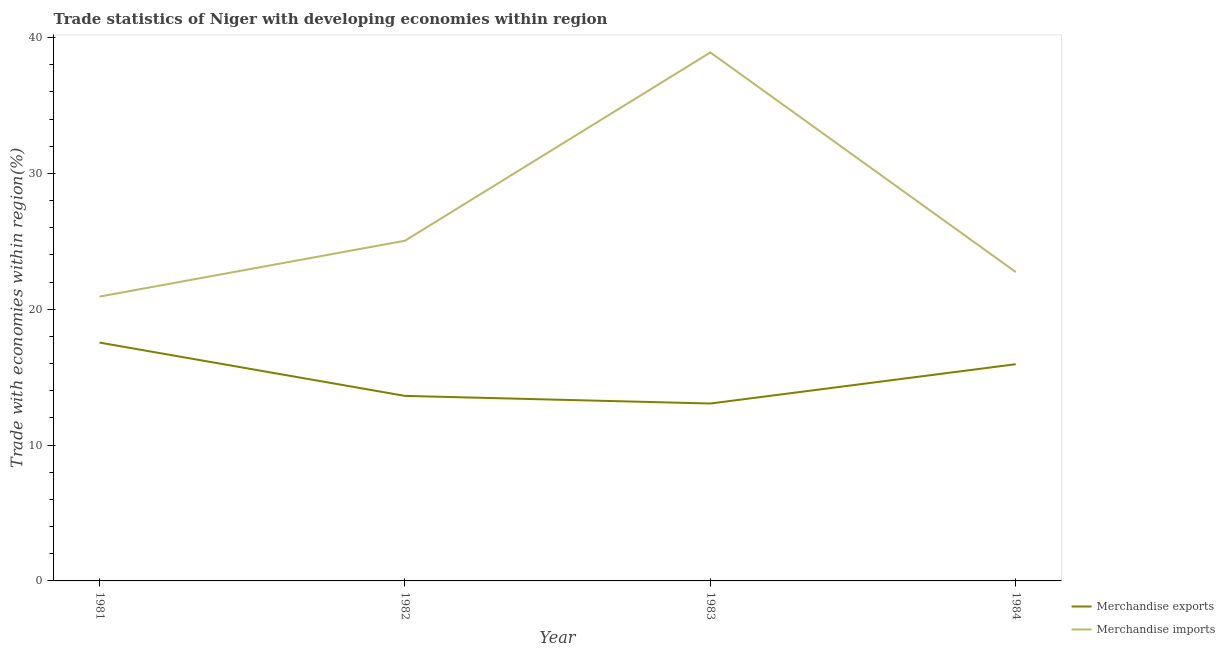How many different coloured lines are there?
Provide a succinct answer. 2. Does the line corresponding to merchandise imports intersect with the line corresponding to merchandise exports?
Your answer should be very brief. No. Is the number of lines equal to the number of legend labels?
Keep it short and to the point. Yes. What is the merchandise exports in 1983?
Give a very brief answer. 13.06. Across all years, what is the maximum merchandise imports?
Make the answer very short. 38.91. Across all years, what is the minimum merchandise imports?
Keep it short and to the point. 20.93. In which year was the merchandise imports maximum?
Your answer should be very brief. 1983. What is the total merchandise exports in the graph?
Provide a short and direct response. 60.18. What is the difference between the merchandise imports in 1981 and that in 1984?
Offer a terse response. -1.81. What is the difference between the merchandise exports in 1984 and the merchandise imports in 1983?
Your answer should be very brief. -22.95. What is the average merchandise imports per year?
Offer a terse response. 26.9. In the year 1981, what is the difference between the merchandise exports and merchandise imports?
Ensure brevity in your answer.  -3.38. What is the ratio of the merchandise exports in 1983 to that in 1984?
Make the answer very short. 0.82. What is the difference between the highest and the second highest merchandise imports?
Provide a short and direct response. 13.86. What is the difference between the highest and the lowest merchandise exports?
Offer a very short reply. 4.49. Is the sum of the merchandise imports in 1981 and 1984 greater than the maximum merchandise exports across all years?
Offer a terse response. Yes. Does the merchandise exports monotonically increase over the years?
Your response must be concise. No. Is the merchandise exports strictly greater than the merchandise imports over the years?
Provide a succinct answer. No. How many lines are there?
Give a very brief answer. 2. How many years are there in the graph?
Make the answer very short. 4. What is the difference between two consecutive major ticks on the Y-axis?
Ensure brevity in your answer.  10. Are the values on the major ticks of Y-axis written in scientific E-notation?
Provide a succinct answer. No. Does the graph contain any zero values?
Ensure brevity in your answer.  No. Does the graph contain grids?
Your response must be concise. No. How many legend labels are there?
Keep it short and to the point. 2. How are the legend labels stacked?
Your answer should be compact. Vertical. What is the title of the graph?
Give a very brief answer. Trade statistics of Niger with developing economies within region. Does "IMF concessional" appear as one of the legend labels in the graph?
Make the answer very short. No. What is the label or title of the X-axis?
Make the answer very short. Year. What is the label or title of the Y-axis?
Provide a short and direct response. Trade with economies within region(%). What is the Trade with economies within region(%) of Merchandise exports in 1981?
Offer a terse response. 17.55. What is the Trade with economies within region(%) in Merchandise imports in 1981?
Your answer should be very brief. 20.93. What is the Trade with economies within region(%) in Merchandise exports in 1982?
Give a very brief answer. 13.62. What is the Trade with economies within region(%) of Merchandise imports in 1982?
Your answer should be compact. 25.04. What is the Trade with economies within region(%) in Merchandise exports in 1983?
Keep it short and to the point. 13.06. What is the Trade with economies within region(%) of Merchandise imports in 1983?
Offer a terse response. 38.91. What is the Trade with economies within region(%) in Merchandise exports in 1984?
Provide a short and direct response. 15.95. What is the Trade with economies within region(%) in Merchandise imports in 1984?
Keep it short and to the point. 22.74. Across all years, what is the maximum Trade with economies within region(%) of Merchandise exports?
Your answer should be very brief. 17.55. Across all years, what is the maximum Trade with economies within region(%) of Merchandise imports?
Keep it short and to the point. 38.91. Across all years, what is the minimum Trade with economies within region(%) in Merchandise exports?
Your answer should be very brief. 13.06. Across all years, what is the minimum Trade with economies within region(%) in Merchandise imports?
Make the answer very short. 20.93. What is the total Trade with economies within region(%) of Merchandise exports in the graph?
Keep it short and to the point. 60.18. What is the total Trade with economies within region(%) of Merchandise imports in the graph?
Give a very brief answer. 107.62. What is the difference between the Trade with economies within region(%) in Merchandise exports in 1981 and that in 1982?
Your response must be concise. 3.93. What is the difference between the Trade with economies within region(%) in Merchandise imports in 1981 and that in 1982?
Your answer should be compact. -4.11. What is the difference between the Trade with economies within region(%) of Merchandise exports in 1981 and that in 1983?
Provide a succinct answer. 4.49. What is the difference between the Trade with economies within region(%) of Merchandise imports in 1981 and that in 1983?
Provide a short and direct response. -17.97. What is the difference between the Trade with economies within region(%) of Merchandise exports in 1981 and that in 1984?
Provide a short and direct response. 1.59. What is the difference between the Trade with economies within region(%) in Merchandise imports in 1981 and that in 1984?
Your answer should be compact. -1.81. What is the difference between the Trade with economies within region(%) in Merchandise exports in 1982 and that in 1983?
Provide a short and direct response. 0.56. What is the difference between the Trade with economies within region(%) in Merchandise imports in 1982 and that in 1983?
Keep it short and to the point. -13.86. What is the difference between the Trade with economies within region(%) of Merchandise exports in 1982 and that in 1984?
Your answer should be compact. -2.33. What is the difference between the Trade with economies within region(%) of Merchandise imports in 1982 and that in 1984?
Provide a short and direct response. 2.31. What is the difference between the Trade with economies within region(%) of Merchandise exports in 1983 and that in 1984?
Your answer should be very brief. -2.89. What is the difference between the Trade with economies within region(%) in Merchandise imports in 1983 and that in 1984?
Your response must be concise. 16.17. What is the difference between the Trade with economies within region(%) of Merchandise exports in 1981 and the Trade with economies within region(%) of Merchandise imports in 1982?
Your answer should be very brief. -7.5. What is the difference between the Trade with economies within region(%) in Merchandise exports in 1981 and the Trade with economies within region(%) in Merchandise imports in 1983?
Give a very brief answer. -21.36. What is the difference between the Trade with economies within region(%) of Merchandise exports in 1981 and the Trade with economies within region(%) of Merchandise imports in 1984?
Your response must be concise. -5.19. What is the difference between the Trade with economies within region(%) in Merchandise exports in 1982 and the Trade with economies within region(%) in Merchandise imports in 1983?
Offer a terse response. -25.28. What is the difference between the Trade with economies within region(%) in Merchandise exports in 1982 and the Trade with economies within region(%) in Merchandise imports in 1984?
Ensure brevity in your answer.  -9.12. What is the difference between the Trade with economies within region(%) of Merchandise exports in 1983 and the Trade with economies within region(%) of Merchandise imports in 1984?
Provide a short and direct response. -9.68. What is the average Trade with economies within region(%) in Merchandise exports per year?
Offer a terse response. 15.04. What is the average Trade with economies within region(%) of Merchandise imports per year?
Offer a very short reply. 26.9. In the year 1981, what is the difference between the Trade with economies within region(%) in Merchandise exports and Trade with economies within region(%) in Merchandise imports?
Provide a succinct answer. -3.38. In the year 1982, what is the difference between the Trade with economies within region(%) of Merchandise exports and Trade with economies within region(%) of Merchandise imports?
Give a very brief answer. -11.42. In the year 1983, what is the difference between the Trade with economies within region(%) in Merchandise exports and Trade with economies within region(%) in Merchandise imports?
Ensure brevity in your answer.  -25.85. In the year 1984, what is the difference between the Trade with economies within region(%) of Merchandise exports and Trade with economies within region(%) of Merchandise imports?
Your response must be concise. -6.78. What is the ratio of the Trade with economies within region(%) of Merchandise exports in 1981 to that in 1982?
Your answer should be very brief. 1.29. What is the ratio of the Trade with economies within region(%) of Merchandise imports in 1981 to that in 1982?
Your response must be concise. 0.84. What is the ratio of the Trade with economies within region(%) in Merchandise exports in 1981 to that in 1983?
Offer a very short reply. 1.34. What is the ratio of the Trade with economies within region(%) of Merchandise imports in 1981 to that in 1983?
Offer a terse response. 0.54. What is the ratio of the Trade with economies within region(%) in Merchandise exports in 1981 to that in 1984?
Give a very brief answer. 1.1. What is the ratio of the Trade with economies within region(%) of Merchandise imports in 1981 to that in 1984?
Make the answer very short. 0.92. What is the ratio of the Trade with economies within region(%) in Merchandise exports in 1982 to that in 1983?
Your answer should be compact. 1.04. What is the ratio of the Trade with economies within region(%) in Merchandise imports in 1982 to that in 1983?
Give a very brief answer. 0.64. What is the ratio of the Trade with economies within region(%) in Merchandise exports in 1982 to that in 1984?
Make the answer very short. 0.85. What is the ratio of the Trade with economies within region(%) of Merchandise imports in 1982 to that in 1984?
Offer a terse response. 1.1. What is the ratio of the Trade with economies within region(%) in Merchandise exports in 1983 to that in 1984?
Make the answer very short. 0.82. What is the ratio of the Trade with economies within region(%) of Merchandise imports in 1983 to that in 1984?
Offer a terse response. 1.71. What is the difference between the highest and the second highest Trade with economies within region(%) in Merchandise exports?
Your response must be concise. 1.59. What is the difference between the highest and the second highest Trade with economies within region(%) in Merchandise imports?
Provide a succinct answer. 13.86. What is the difference between the highest and the lowest Trade with economies within region(%) of Merchandise exports?
Keep it short and to the point. 4.49. What is the difference between the highest and the lowest Trade with economies within region(%) of Merchandise imports?
Make the answer very short. 17.97. 